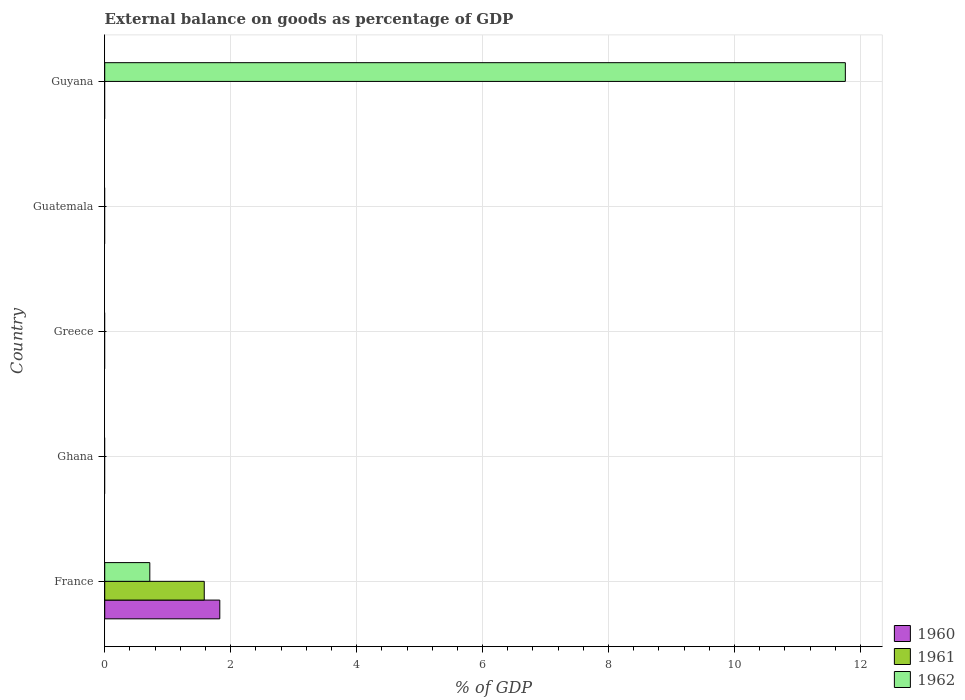How many bars are there on the 1st tick from the top?
Make the answer very short. 1. How many bars are there on the 2nd tick from the bottom?
Offer a terse response. 0. What is the external balance on goods as percentage of GDP in 1962 in Guyana?
Your answer should be compact. 11.76. Across all countries, what is the maximum external balance on goods as percentage of GDP in 1961?
Give a very brief answer. 1.58. What is the total external balance on goods as percentage of GDP in 1960 in the graph?
Your answer should be very brief. 1.83. What is the average external balance on goods as percentage of GDP in 1962 per country?
Provide a succinct answer. 2.5. What is the difference between the external balance on goods as percentage of GDP in 1962 and external balance on goods as percentage of GDP in 1960 in France?
Your response must be concise. -1.11. In how many countries, is the external balance on goods as percentage of GDP in 1962 greater than 8.8 %?
Make the answer very short. 1. What is the difference between the highest and the lowest external balance on goods as percentage of GDP in 1962?
Your response must be concise. 11.76. Is it the case that in every country, the sum of the external balance on goods as percentage of GDP in 1961 and external balance on goods as percentage of GDP in 1962 is greater than the external balance on goods as percentage of GDP in 1960?
Provide a short and direct response. No. Are all the bars in the graph horizontal?
Provide a succinct answer. Yes. What is the difference between two consecutive major ticks on the X-axis?
Make the answer very short. 2. Are the values on the major ticks of X-axis written in scientific E-notation?
Provide a succinct answer. No. Does the graph contain any zero values?
Offer a very short reply. Yes. Does the graph contain grids?
Ensure brevity in your answer.  Yes. How many legend labels are there?
Offer a very short reply. 3. What is the title of the graph?
Your answer should be very brief. External balance on goods as percentage of GDP. Does "1961" appear as one of the legend labels in the graph?
Make the answer very short. Yes. What is the label or title of the X-axis?
Provide a succinct answer. % of GDP. What is the label or title of the Y-axis?
Provide a succinct answer. Country. What is the % of GDP in 1960 in France?
Keep it short and to the point. 1.83. What is the % of GDP in 1961 in France?
Ensure brevity in your answer.  1.58. What is the % of GDP of 1962 in France?
Keep it short and to the point. 0.72. What is the % of GDP in 1962 in Ghana?
Give a very brief answer. 0. What is the % of GDP in 1961 in Greece?
Ensure brevity in your answer.  0. What is the % of GDP of 1962 in Greece?
Offer a very short reply. 0. What is the % of GDP in 1961 in Guatemala?
Make the answer very short. 0. What is the % of GDP in 1962 in Guyana?
Your answer should be very brief. 11.76. Across all countries, what is the maximum % of GDP of 1960?
Keep it short and to the point. 1.83. Across all countries, what is the maximum % of GDP of 1961?
Your response must be concise. 1.58. Across all countries, what is the maximum % of GDP in 1962?
Make the answer very short. 11.76. Across all countries, what is the minimum % of GDP in 1961?
Provide a short and direct response. 0. Across all countries, what is the minimum % of GDP in 1962?
Ensure brevity in your answer.  0. What is the total % of GDP in 1960 in the graph?
Make the answer very short. 1.83. What is the total % of GDP of 1961 in the graph?
Your response must be concise. 1.58. What is the total % of GDP of 1962 in the graph?
Provide a short and direct response. 12.48. What is the difference between the % of GDP of 1962 in France and that in Guyana?
Ensure brevity in your answer.  -11.04. What is the difference between the % of GDP of 1960 in France and the % of GDP of 1962 in Guyana?
Your response must be concise. -9.93. What is the difference between the % of GDP in 1961 in France and the % of GDP in 1962 in Guyana?
Make the answer very short. -10.18. What is the average % of GDP in 1960 per country?
Provide a succinct answer. 0.37. What is the average % of GDP in 1961 per country?
Keep it short and to the point. 0.32. What is the average % of GDP in 1962 per country?
Provide a succinct answer. 2.5. What is the difference between the % of GDP of 1960 and % of GDP of 1961 in France?
Offer a terse response. 0.25. What is the difference between the % of GDP in 1960 and % of GDP in 1962 in France?
Give a very brief answer. 1.11. What is the difference between the % of GDP of 1961 and % of GDP of 1962 in France?
Your response must be concise. 0.86. What is the ratio of the % of GDP of 1962 in France to that in Guyana?
Your answer should be very brief. 0.06. What is the difference between the highest and the lowest % of GDP in 1960?
Make the answer very short. 1.83. What is the difference between the highest and the lowest % of GDP in 1961?
Keep it short and to the point. 1.58. What is the difference between the highest and the lowest % of GDP of 1962?
Give a very brief answer. 11.76. 